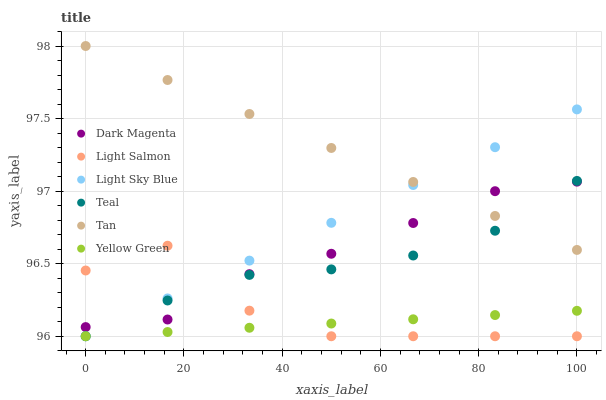Does Yellow Green have the minimum area under the curve?
Answer yes or no. Yes. Does Tan have the maximum area under the curve?
Answer yes or no. Yes. Does Dark Magenta have the minimum area under the curve?
Answer yes or no. No. Does Dark Magenta have the maximum area under the curve?
Answer yes or no. No. Is Yellow Green the smoothest?
Answer yes or no. Yes. Is Light Salmon the roughest?
Answer yes or no. Yes. Is Dark Magenta the smoothest?
Answer yes or no. No. Is Dark Magenta the roughest?
Answer yes or no. No. Does Light Salmon have the lowest value?
Answer yes or no. Yes. Does Dark Magenta have the lowest value?
Answer yes or no. No. Does Tan have the highest value?
Answer yes or no. Yes. Does Dark Magenta have the highest value?
Answer yes or no. No. Is Yellow Green less than Dark Magenta?
Answer yes or no. Yes. Is Tan greater than Yellow Green?
Answer yes or no. Yes. Does Dark Magenta intersect Tan?
Answer yes or no. Yes. Is Dark Magenta less than Tan?
Answer yes or no. No. Is Dark Magenta greater than Tan?
Answer yes or no. No. Does Yellow Green intersect Dark Magenta?
Answer yes or no. No. 